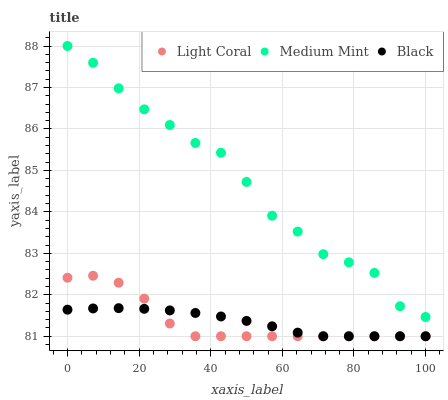Does Light Coral have the minimum area under the curve?
Answer yes or no. Yes. Does Medium Mint have the maximum area under the curve?
Answer yes or no. Yes. Does Black have the minimum area under the curve?
Answer yes or no. No. Does Black have the maximum area under the curve?
Answer yes or no. No. Is Black the smoothest?
Answer yes or no. Yes. Is Medium Mint the roughest?
Answer yes or no. Yes. Is Medium Mint the smoothest?
Answer yes or no. No. Is Black the roughest?
Answer yes or no. No. Does Light Coral have the lowest value?
Answer yes or no. Yes. Does Medium Mint have the lowest value?
Answer yes or no. No. Does Medium Mint have the highest value?
Answer yes or no. Yes. Does Black have the highest value?
Answer yes or no. No. Is Light Coral less than Medium Mint?
Answer yes or no. Yes. Is Medium Mint greater than Black?
Answer yes or no. Yes. Does Light Coral intersect Black?
Answer yes or no. Yes. Is Light Coral less than Black?
Answer yes or no. No. Is Light Coral greater than Black?
Answer yes or no. No. Does Light Coral intersect Medium Mint?
Answer yes or no. No. 